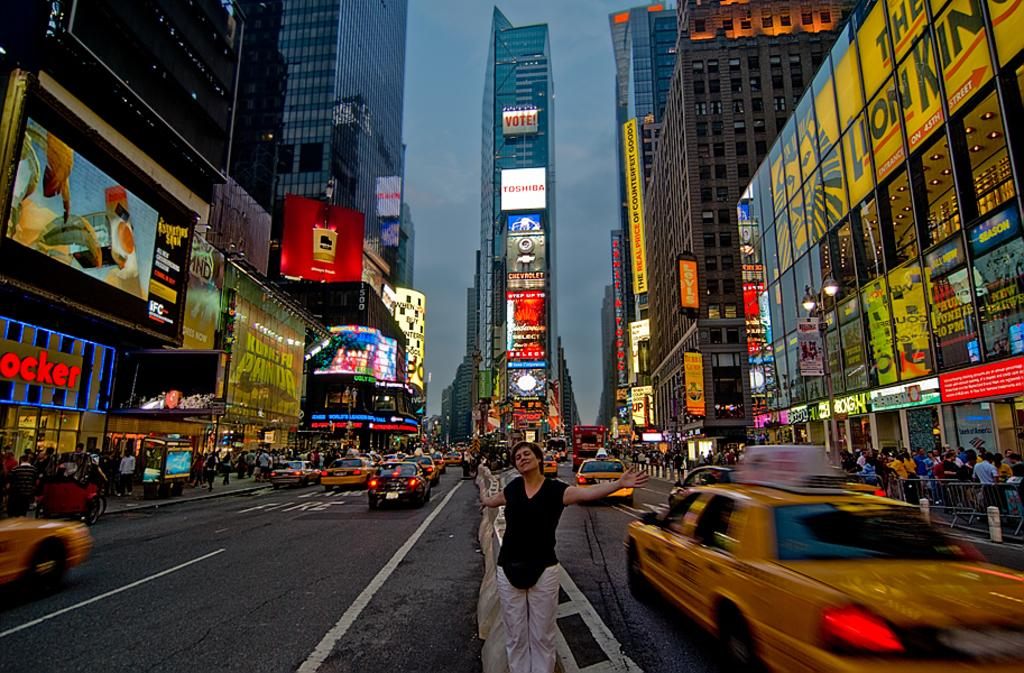<image>
Render a clear and concise summary of the photo. A tall building is adorned with many advertisements, including one for Toshiba. 